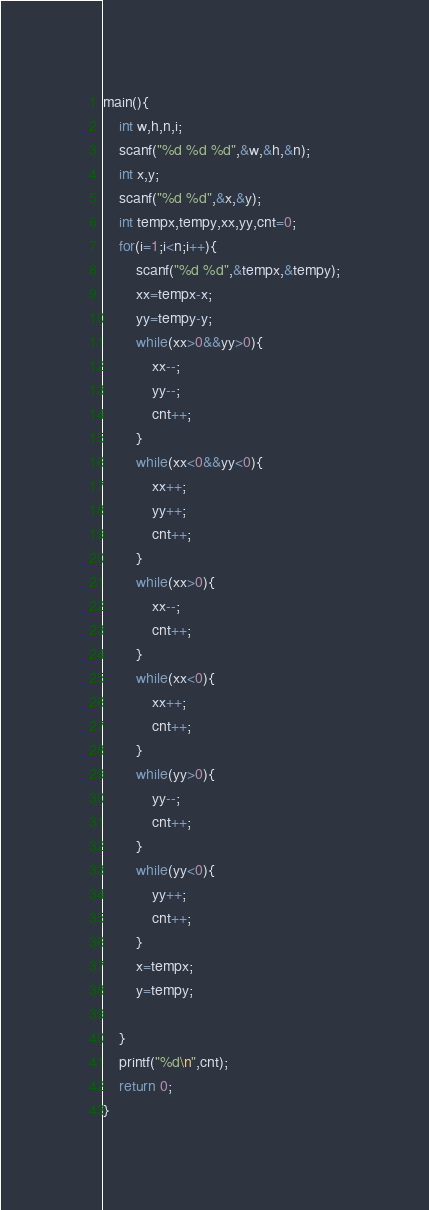Convert code to text. <code><loc_0><loc_0><loc_500><loc_500><_C_>
main(){
    int w,h,n,i;
    scanf("%d %d %d",&w,&h,&n);
    int x,y;
    scanf("%d %d",&x,&y);
    int tempx,tempy,xx,yy,cnt=0;
    for(i=1;i<n;i++){
        scanf("%d %d",&tempx,&tempy);
        xx=tempx-x;
        yy=tempy-y;
        while(xx>0&&yy>0){
            xx--;
            yy--;
            cnt++;
        }
        while(xx<0&&yy<0){
            xx++;
            yy++;
            cnt++;
        }
        while(xx>0){
            xx--;
            cnt++;
        }
        while(xx<0){
            xx++;
            cnt++;
        }
        while(yy>0){
            yy--;
            cnt++;
        }
        while(yy<0){
            yy++;
            cnt++;
        }
        x=tempx;
        y=tempy;
       
    }
    printf("%d\n",cnt);
    return 0;
}</code> 